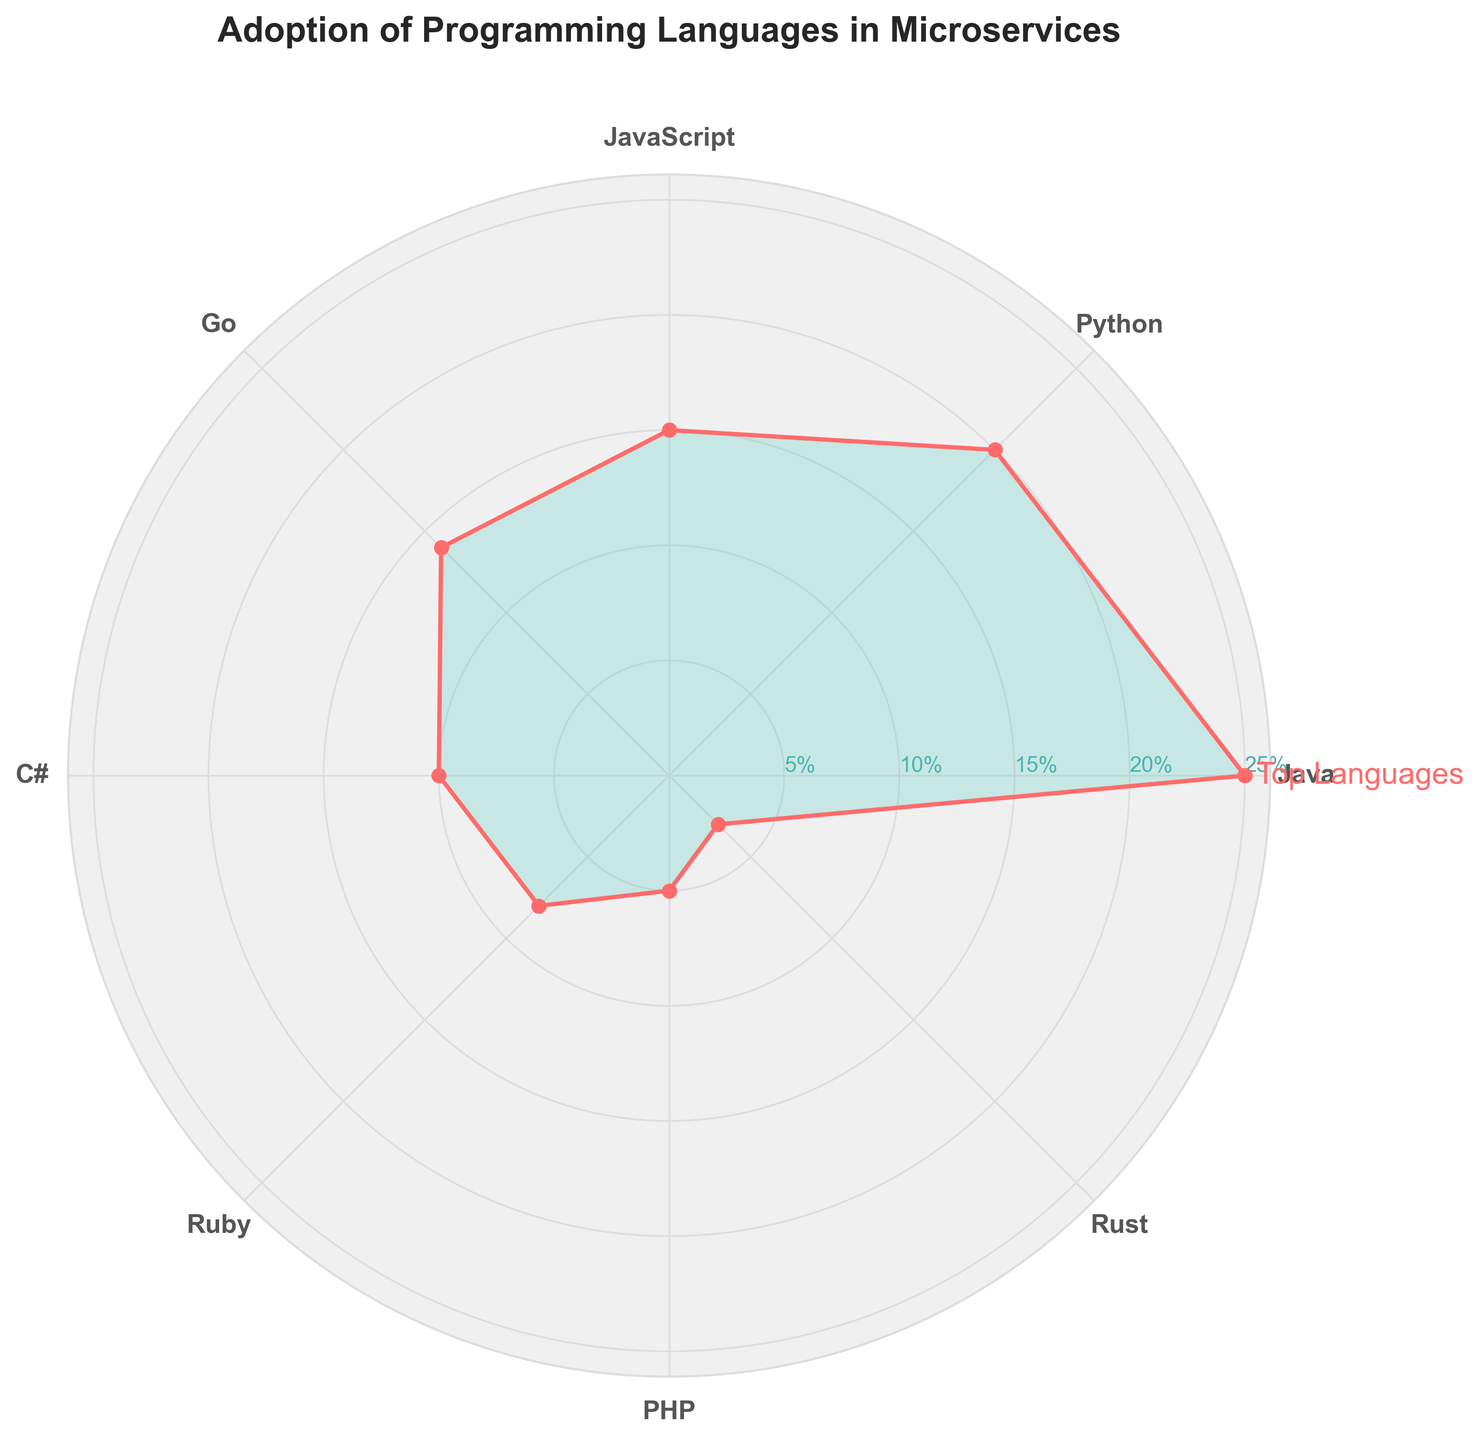What is the title of the figure? The title of the figure is usually found at the top of the plot. In this plot, it clearly states the subject of the data being shown.
Answer: Adoption of Programming Languages in Microservices Which programming language has the highest adoption percentage? Look for the programming language with the longest extension on the radial axis of the rose chart.
Answer: Java How many programming languages are represented in the chart? Count the number of distinct programming languages labeled around the polar plot.
Answer: 8 What is the total adoption percentage of Python and JavaScript combined? Identify the segments for Python and JavaScript, read their respective percentages, and then add them together. Python is 20% and JavaScript is 15%. Summing them up gives 20 + 15.
Answer: 35% Which programming languages have an adoption percentage lower than 10%? Look for the segments that extend below the 10% radial marker. In this plot, Ruby, PHP, and Rust fall in this category.
Answer: Ruby, PHP, Rust What is the difference in adoption percentage between Go and C#? Identify the segments for Go and C#, and read their respective percentages. Go is 14% and C# is 10%. Subtract the smaller percentage from the larger one: 14 - 10.
Answer: 4% What is the average adoption percentage of the top three programming languages? Identify the top three languages by their adoption percentages, which are Java (25%), Python (20%), and JavaScript (15%). Then, sum these percentages and divide by three: (25 + 20 + 15) / 3.
Answer: 20% Is Python or Go more popular, according to the chart? Compare the lengths of the segments for Python and Go. Python is longer and has a higher percentage.
Answer: Python What is the percentage difference between the most and least adopted programming languages? Identify the most adopted (Java at 25%) and the least adopted (Rust at 3%) languages. Subtract the least from the most: 25 - 3.
Answer: 22% How does the adoption of C# compare to Ruby? Compare the segment lengths for C# and Ruby. C# has a longer segment, indicating a higher percentage.
Answer: C# is higher 